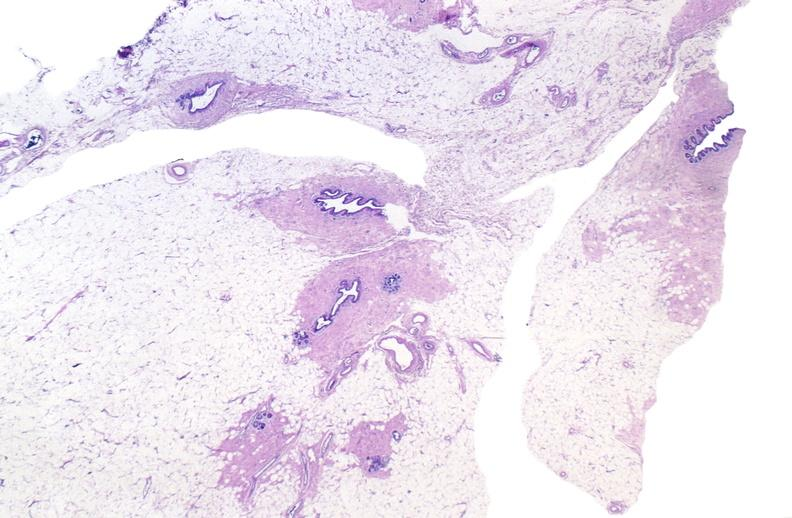does this image show normal breast?
Answer the question using a single word or phrase. Yes 